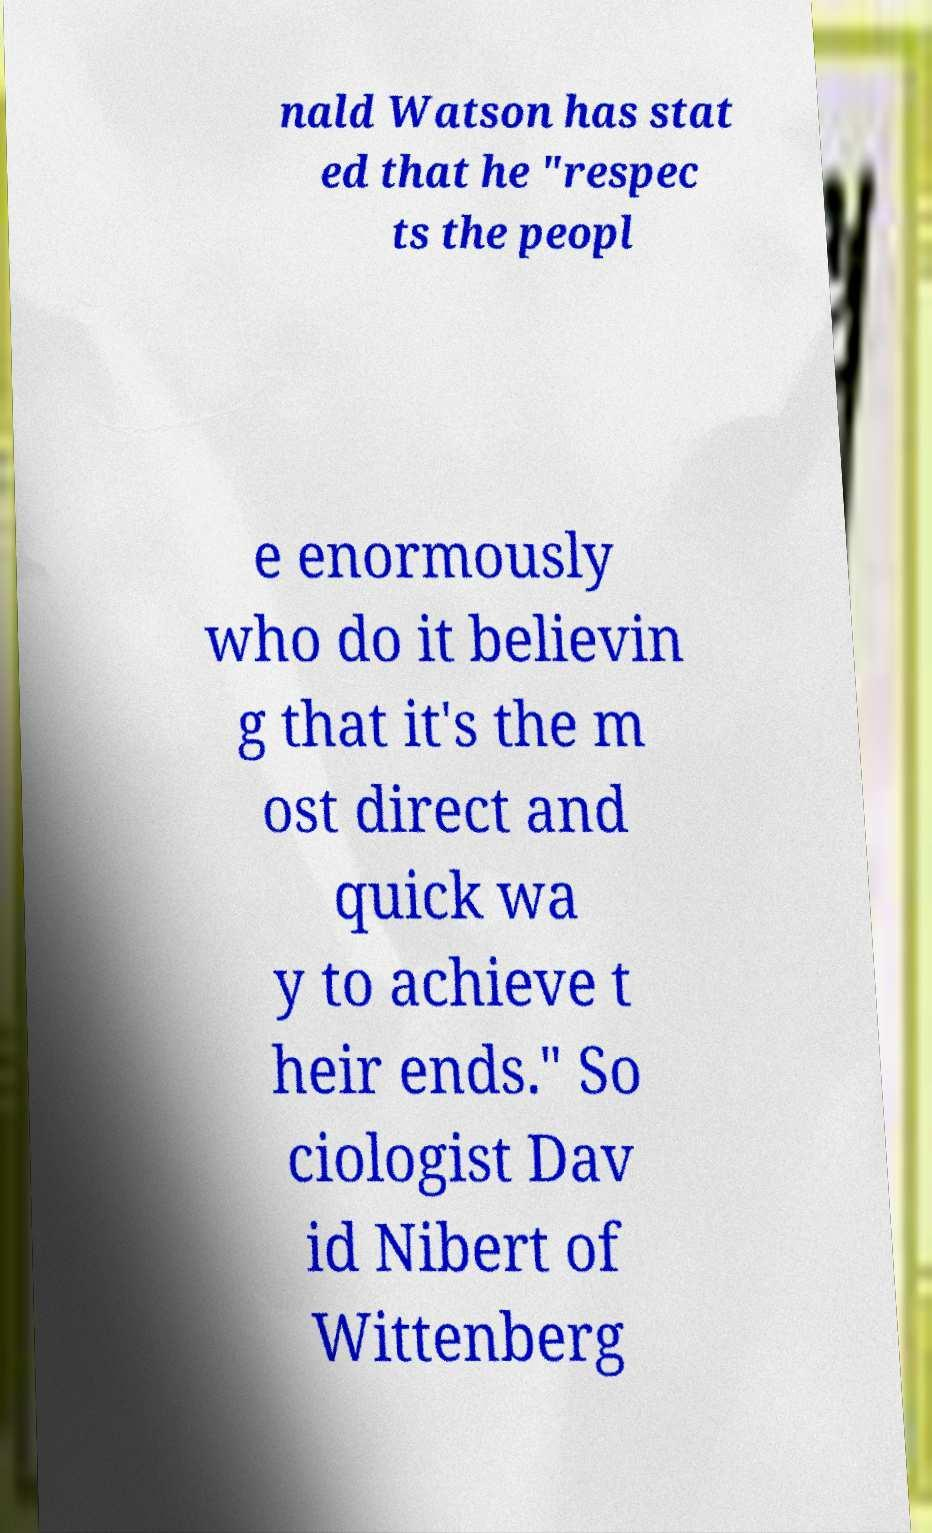Could you assist in decoding the text presented in this image and type it out clearly? nald Watson has stat ed that he "respec ts the peopl e enormously who do it believin g that it's the m ost direct and quick wa y to achieve t heir ends." So ciologist Dav id Nibert of Wittenberg 